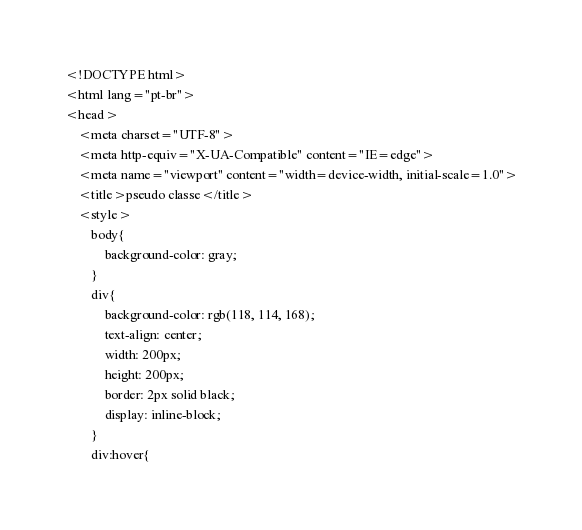<code> <loc_0><loc_0><loc_500><loc_500><_HTML_><!DOCTYPE html>
<html lang="pt-br">
<head>
    <meta charset="UTF-8">
    <meta http-equiv="X-UA-Compatible" content="IE=edge">
    <meta name="viewport" content="width=device-width, initial-scale=1.0">
    <title>pseudo classe</title>
    <style>
        body{
            background-color: gray;
        }
        div{
            background-color: rgb(118, 114, 168);
            text-align: center;
            width: 200px;
            height: 200px;
            border: 2px solid black;
            display: inline-block;
        }
        div:hover{</code> 